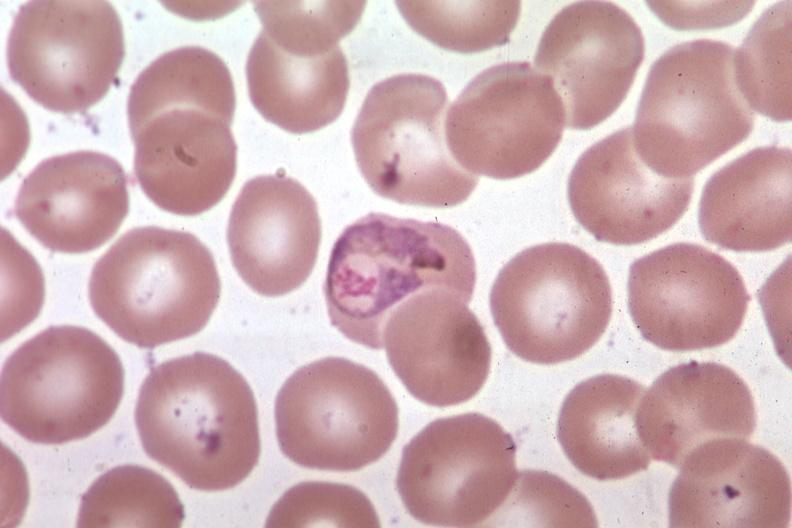what does this image show?
Answer the question using a single word or phrase. Oil wrights excellent 